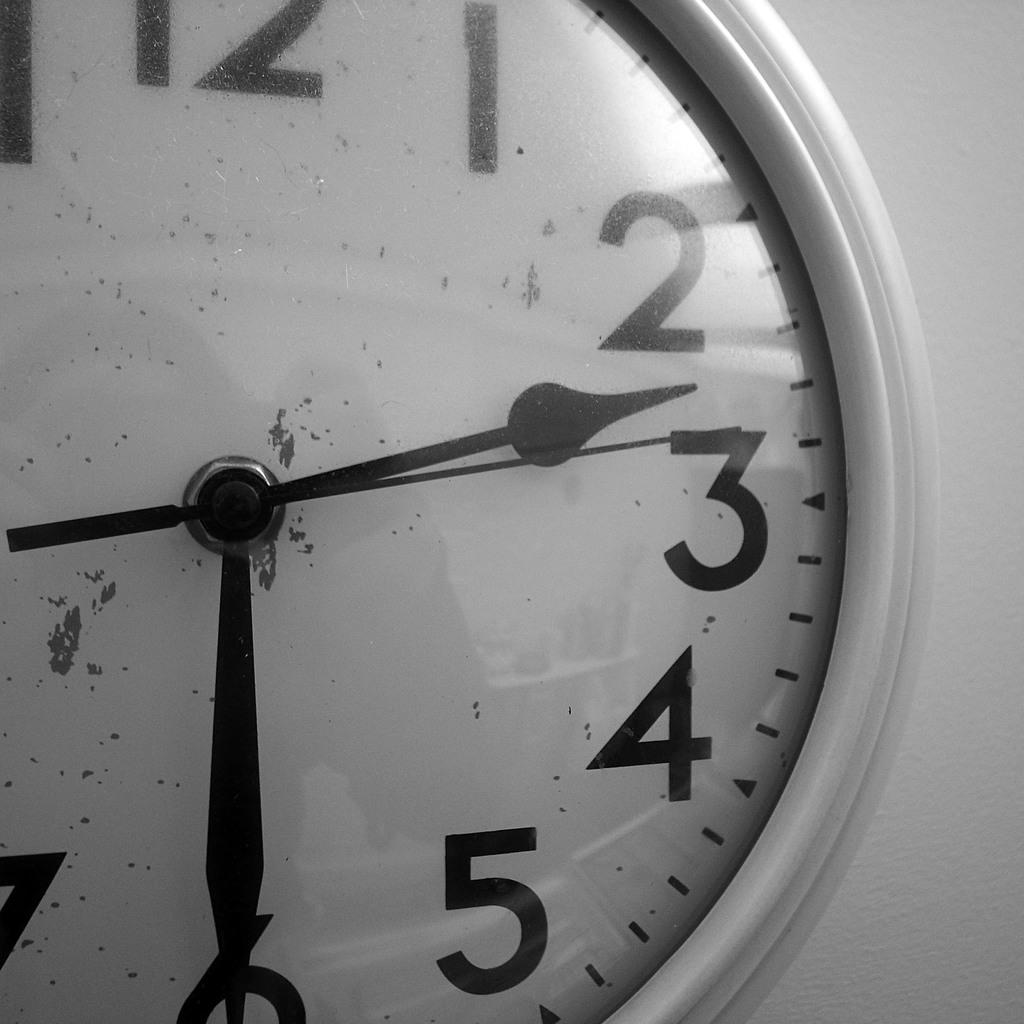<image>
Share a concise interpretation of the image provided. A wall clock with a white face and black hands showing the time of 2:30. 